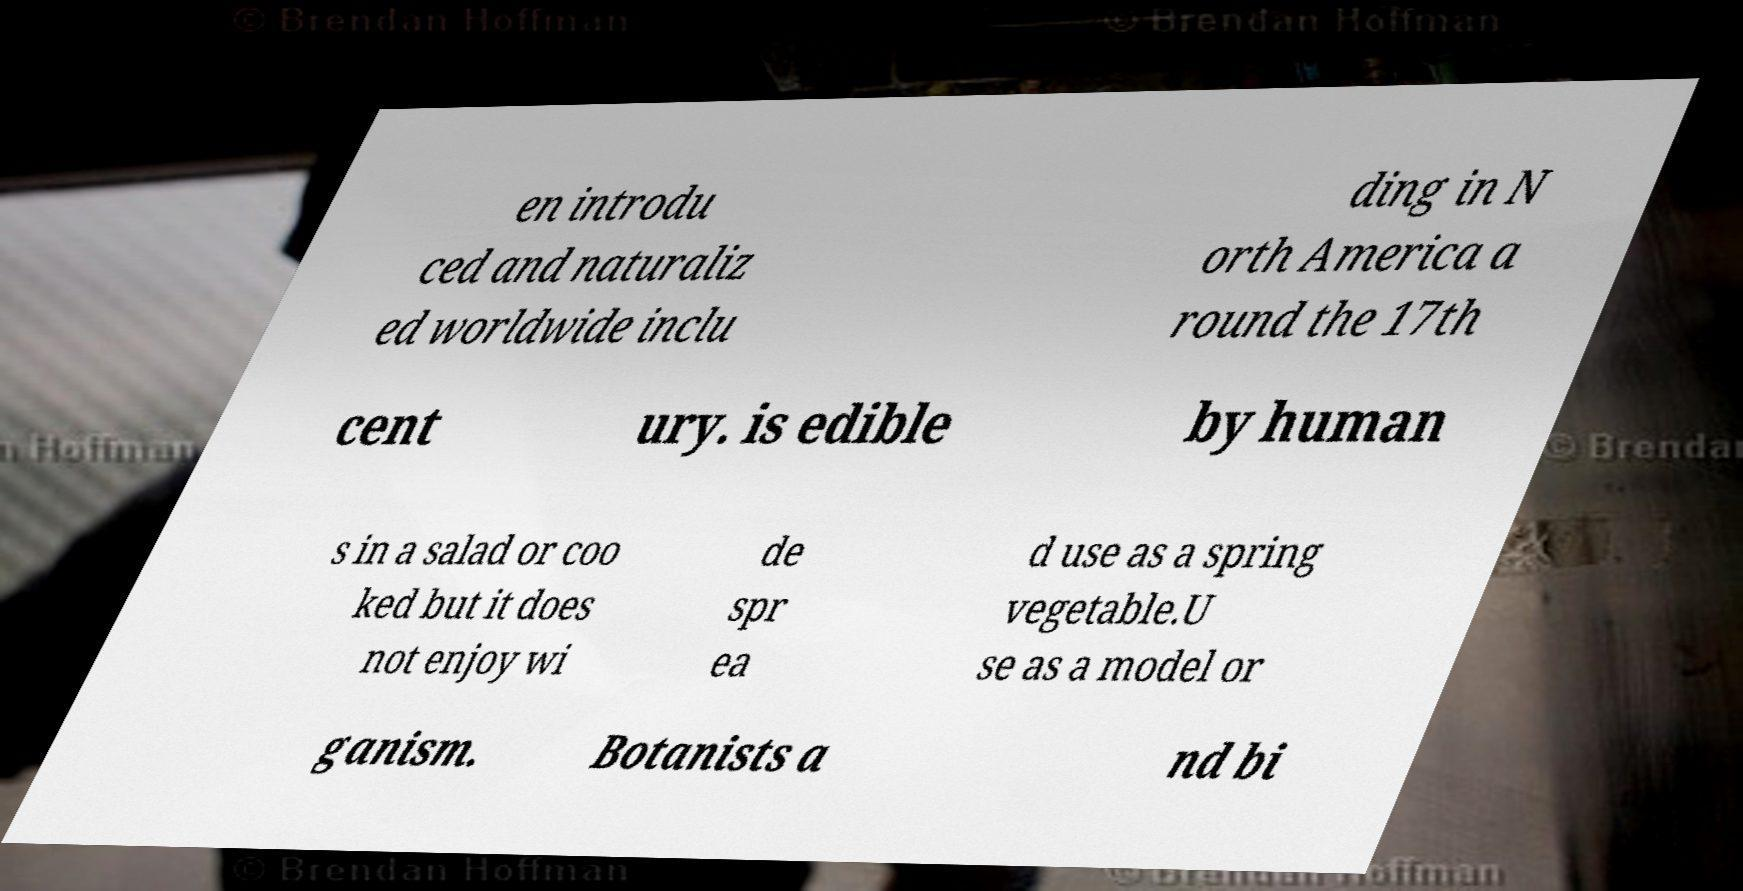What messages or text are displayed in this image? I need them in a readable, typed format. en introdu ced and naturaliz ed worldwide inclu ding in N orth America a round the 17th cent ury. is edible by human s in a salad or coo ked but it does not enjoy wi de spr ea d use as a spring vegetable.U se as a model or ganism. Botanists a nd bi 